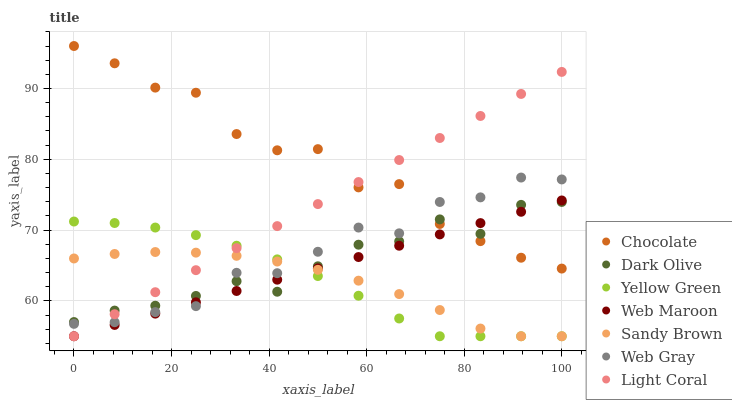Does Sandy Brown have the minimum area under the curve?
Answer yes or no. Yes. Does Chocolate have the maximum area under the curve?
Answer yes or no. Yes. Does Yellow Green have the minimum area under the curve?
Answer yes or no. No. Does Yellow Green have the maximum area under the curve?
Answer yes or no. No. Is Web Maroon the smoothest?
Answer yes or no. Yes. Is Chocolate the roughest?
Answer yes or no. Yes. Is Yellow Green the smoothest?
Answer yes or no. No. Is Yellow Green the roughest?
Answer yes or no. No. Does Yellow Green have the lowest value?
Answer yes or no. Yes. Does Dark Olive have the lowest value?
Answer yes or no. No. Does Chocolate have the highest value?
Answer yes or no. Yes. Does Yellow Green have the highest value?
Answer yes or no. No. Is Yellow Green less than Chocolate?
Answer yes or no. Yes. Is Chocolate greater than Sandy Brown?
Answer yes or no. Yes. Does Dark Olive intersect Sandy Brown?
Answer yes or no. Yes. Is Dark Olive less than Sandy Brown?
Answer yes or no. No. Is Dark Olive greater than Sandy Brown?
Answer yes or no. No. Does Yellow Green intersect Chocolate?
Answer yes or no. No. 